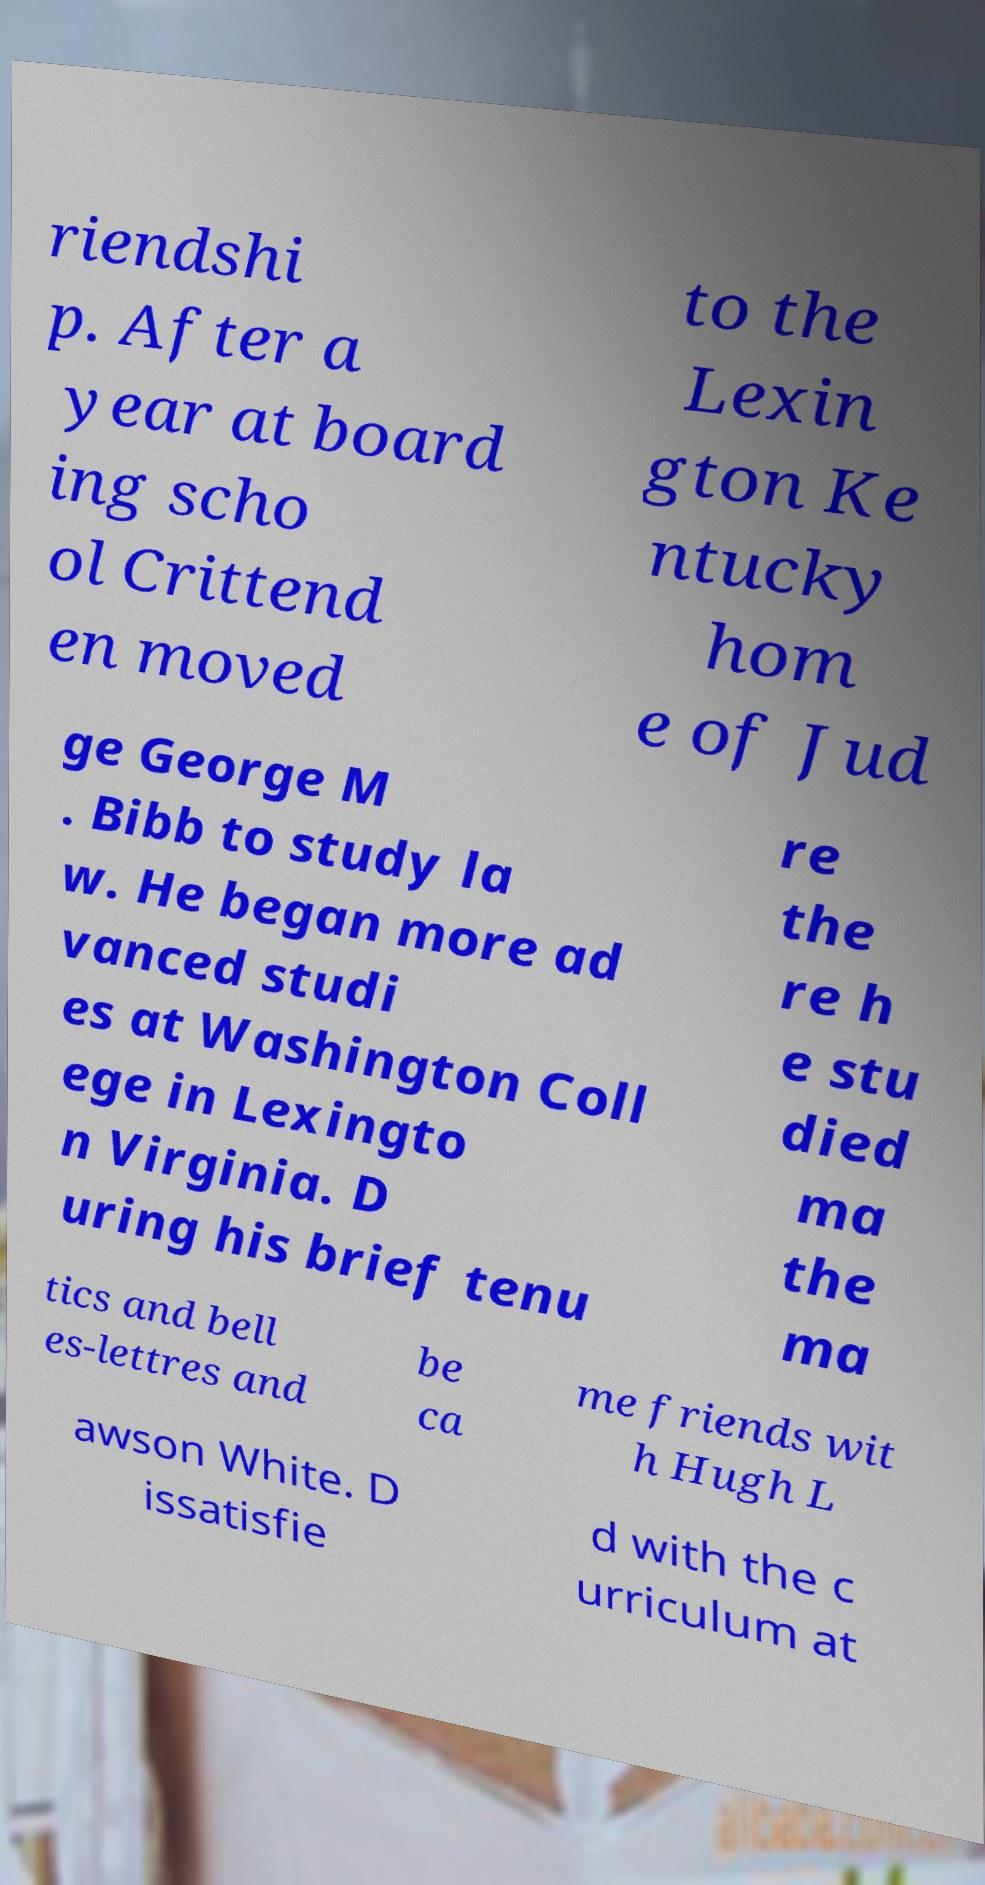For documentation purposes, I need the text within this image transcribed. Could you provide that? riendshi p. After a year at board ing scho ol Crittend en moved to the Lexin gton Ke ntucky hom e of Jud ge George M . Bibb to study la w. He began more ad vanced studi es at Washington Coll ege in Lexingto n Virginia. D uring his brief tenu re the re h e stu died ma the ma tics and bell es-lettres and be ca me friends wit h Hugh L awson White. D issatisfie d with the c urriculum at 